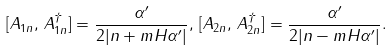Convert formula to latex. <formula><loc_0><loc_0><loc_500><loc_500>[ A _ { 1 n } , \, A _ { 1 n } ^ { \dagger } ] = \frac { \alpha ^ { \prime } } { 2 | n + m H \alpha ^ { \prime } | } , \, [ A _ { 2 n } , \, A _ { 2 n } ^ { \dagger } ] = \frac { \alpha ^ { \prime } } { 2 | n - m H \alpha ^ { \prime } | } .</formula> 